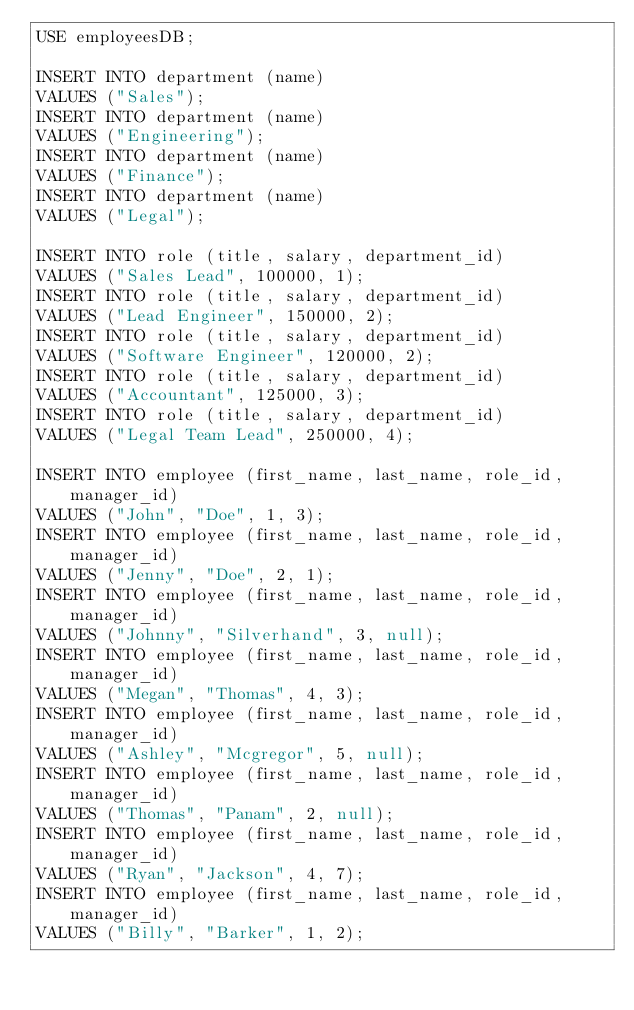Convert code to text. <code><loc_0><loc_0><loc_500><loc_500><_SQL_>USE employeesDB;

INSERT INTO department (name)
VALUES ("Sales");
INSERT INTO department (name)
VALUES ("Engineering");
INSERT INTO department (name)
VALUES ("Finance");
INSERT INTO department (name)
VALUES ("Legal");

INSERT INTO role (title, salary, department_id)
VALUES ("Sales Lead", 100000, 1);
INSERT INTO role (title, salary, department_id)
VALUES ("Lead Engineer", 150000, 2);
INSERT INTO role (title, salary, department_id)
VALUES ("Software Engineer", 120000, 2);
INSERT INTO role (title, salary, department_id)
VALUES ("Accountant", 125000, 3);
INSERT INTO role (title, salary, department_id)
VALUES ("Legal Team Lead", 250000, 4);

INSERT INTO employee (first_name, last_name, role_id, manager_id)
VALUES ("John", "Doe", 1, 3);
INSERT INTO employee (first_name, last_name, role_id, manager_id)
VALUES ("Jenny", "Doe", 2, 1);
INSERT INTO employee (first_name, last_name, role_id, manager_id)
VALUES ("Johnny", "Silverhand", 3, null);
INSERT INTO employee (first_name, last_name, role_id, manager_id)
VALUES ("Megan", "Thomas", 4, 3);
INSERT INTO employee (first_name, last_name, role_id, manager_id)
VALUES ("Ashley", "Mcgregor", 5, null);
INSERT INTO employee (first_name, last_name, role_id, manager_id)
VALUES ("Thomas", "Panam", 2, null);
INSERT INTO employee (first_name, last_name, role_id, manager_id)
VALUES ("Ryan", "Jackson", 4, 7);
INSERT INTO employee (first_name, last_name, role_id, manager_id)
VALUES ("Billy", "Barker", 1, 2);</code> 